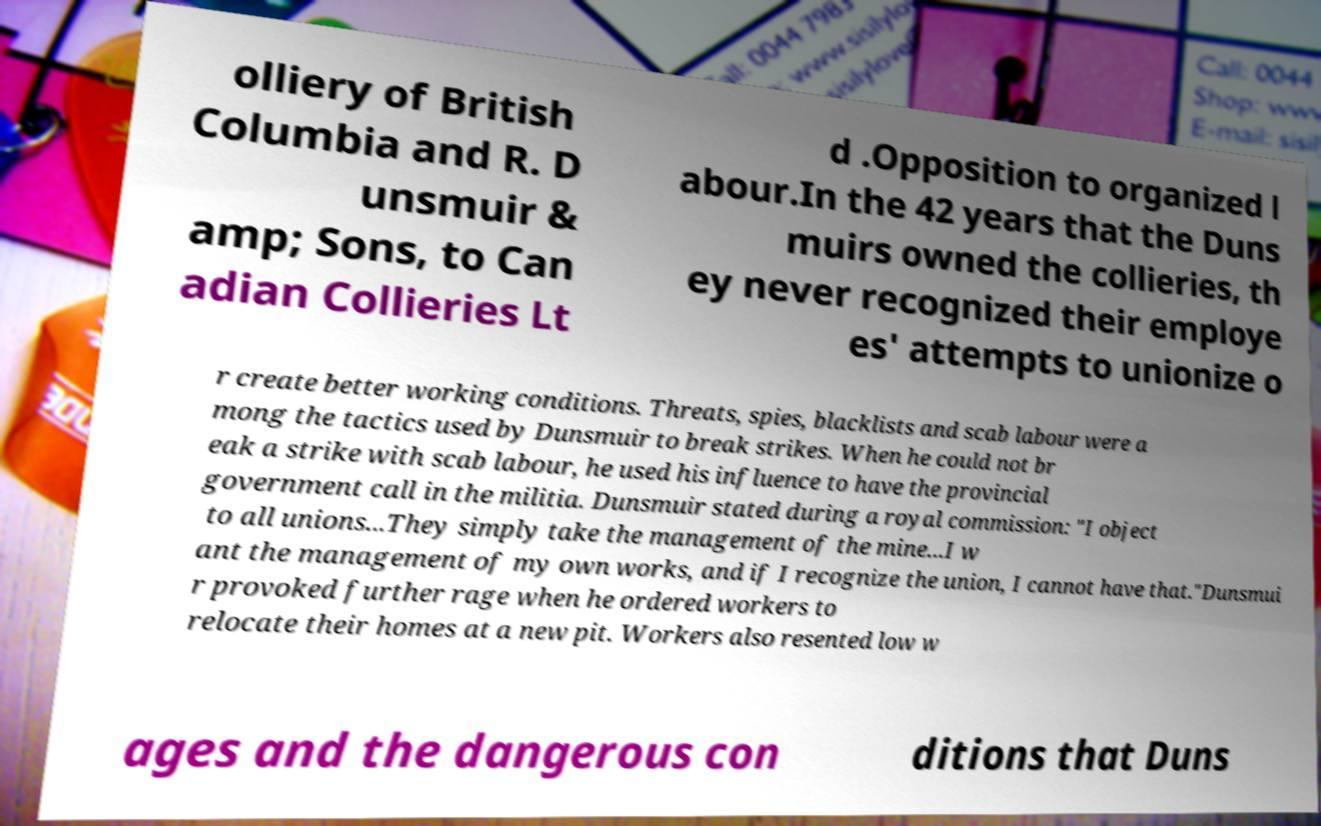Please identify and transcribe the text found in this image. olliery of British Columbia and R. D unsmuir & amp; Sons, to Can adian Collieries Lt d .Opposition to organized l abour.In the 42 years that the Duns muirs owned the collieries, th ey never recognized their employe es' attempts to unionize o r create better working conditions. Threats, spies, blacklists and scab labour were a mong the tactics used by Dunsmuir to break strikes. When he could not br eak a strike with scab labour, he used his influence to have the provincial government call in the militia. Dunsmuir stated during a royal commission: "I object to all unions...They simply take the management of the mine...I w ant the management of my own works, and if I recognize the union, I cannot have that."Dunsmui r provoked further rage when he ordered workers to relocate their homes at a new pit. Workers also resented low w ages and the dangerous con ditions that Duns 